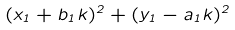<formula> <loc_0><loc_0><loc_500><loc_500>( x _ { 1 } + b _ { 1 } k ) ^ { 2 } + ( y _ { 1 } - a _ { 1 } k ) ^ { 2 }</formula> 